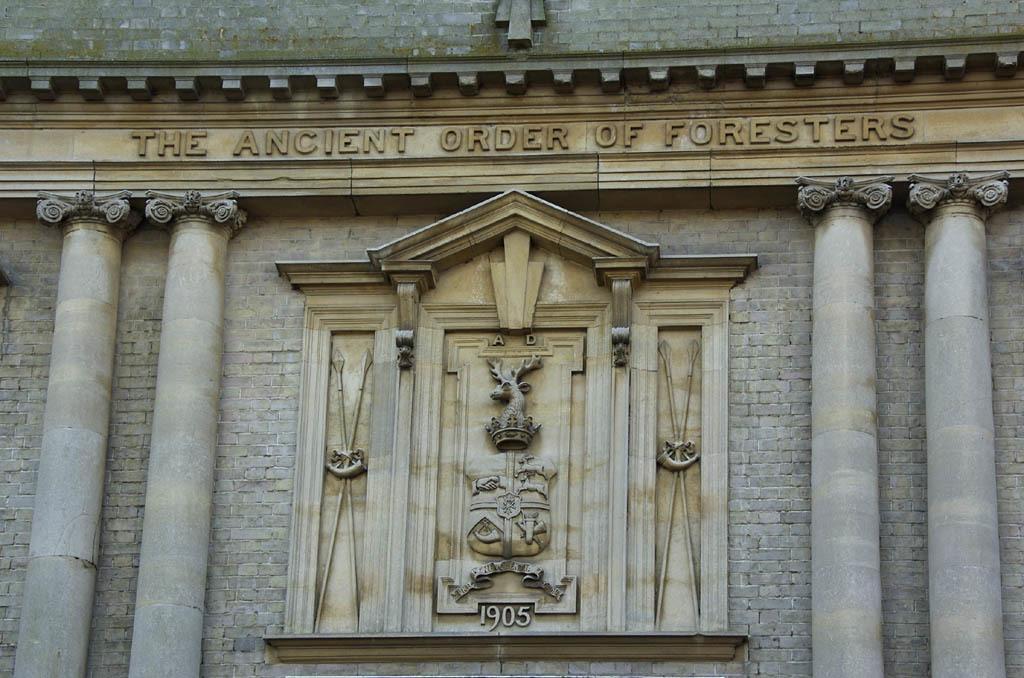Describe this image in one or two sentences. In this image we can see a structure which looks like a palace and there are some sculptures on the wall and we can see some text on the wall. 